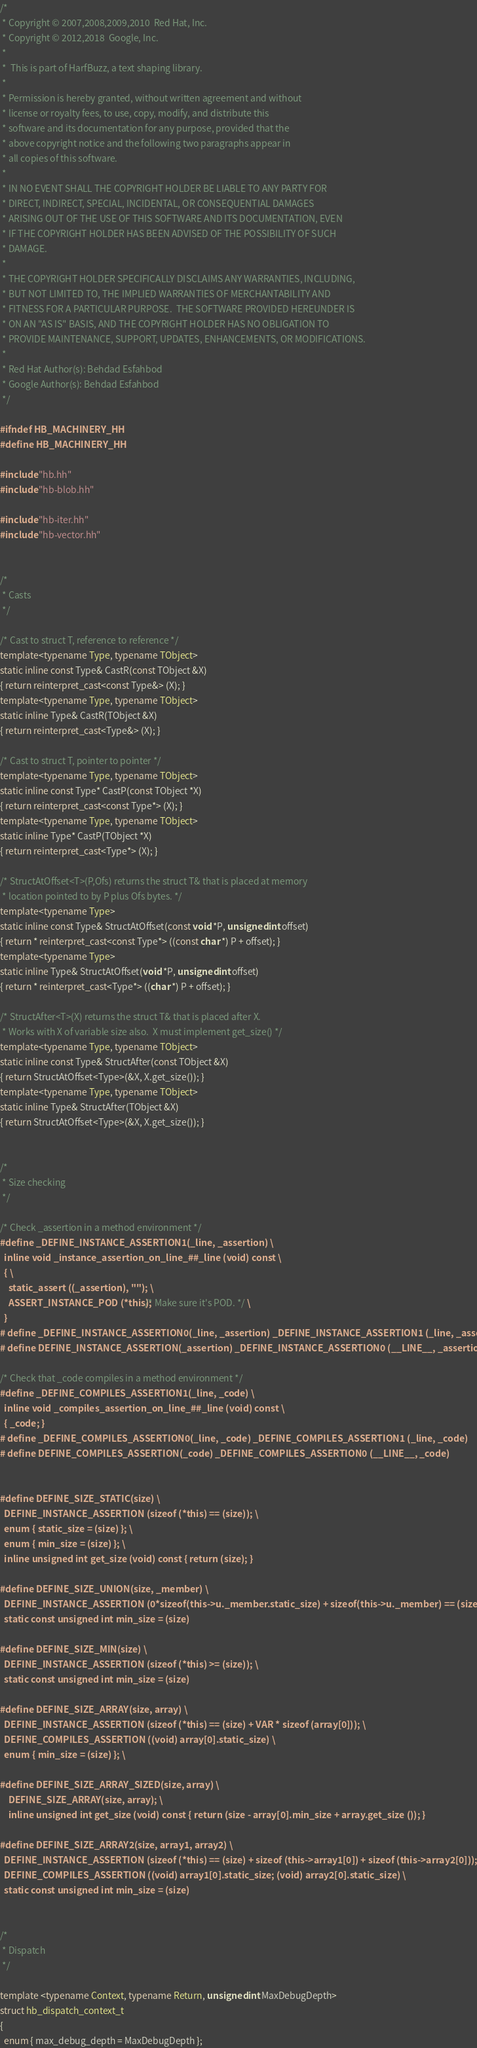Convert code to text. <code><loc_0><loc_0><loc_500><loc_500><_C++_>/*
 * Copyright © 2007,2008,2009,2010  Red Hat, Inc.
 * Copyright © 2012,2018  Google, Inc.
 *
 *  This is part of HarfBuzz, a text shaping library.
 *
 * Permission is hereby granted, without written agreement and without
 * license or royalty fees, to use, copy, modify, and distribute this
 * software and its documentation for any purpose, provided that the
 * above copyright notice and the following two paragraphs appear in
 * all copies of this software.
 *
 * IN NO EVENT SHALL THE COPYRIGHT HOLDER BE LIABLE TO ANY PARTY FOR
 * DIRECT, INDIRECT, SPECIAL, INCIDENTAL, OR CONSEQUENTIAL DAMAGES
 * ARISING OUT OF THE USE OF THIS SOFTWARE AND ITS DOCUMENTATION, EVEN
 * IF THE COPYRIGHT HOLDER HAS BEEN ADVISED OF THE POSSIBILITY OF SUCH
 * DAMAGE.
 *
 * THE COPYRIGHT HOLDER SPECIFICALLY DISCLAIMS ANY WARRANTIES, INCLUDING,
 * BUT NOT LIMITED TO, THE IMPLIED WARRANTIES OF MERCHANTABILITY AND
 * FITNESS FOR A PARTICULAR PURPOSE.  THE SOFTWARE PROVIDED HEREUNDER IS
 * ON AN "AS IS" BASIS, AND THE COPYRIGHT HOLDER HAS NO OBLIGATION TO
 * PROVIDE MAINTENANCE, SUPPORT, UPDATES, ENHANCEMENTS, OR MODIFICATIONS.
 *
 * Red Hat Author(s): Behdad Esfahbod
 * Google Author(s): Behdad Esfahbod
 */

#ifndef HB_MACHINERY_HH
#define HB_MACHINERY_HH

#include "hb.hh"
#include "hb-blob.hh"

#include "hb-iter.hh"
#include "hb-vector.hh"


/*
 * Casts
 */

/* Cast to struct T, reference to reference */
template<typename Type, typename TObject>
static inline const Type& CastR(const TObject &X)
{ return reinterpret_cast<const Type&> (X); }
template<typename Type, typename TObject>
static inline Type& CastR(TObject &X)
{ return reinterpret_cast<Type&> (X); }

/* Cast to struct T, pointer to pointer */
template<typename Type, typename TObject>
static inline const Type* CastP(const TObject *X)
{ return reinterpret_cast<const Type*> (X); }
template<typename Type, typename TObject>
static inline Type* CastP(TObject *X)
{ return reinterpret_cast<Type*> (X); }

/* StructAtOffset<T>(P,Ofs) returns the struct T& that is placed at memory
 * location pointed to by P plus Ofs bytes. */
template<typename Type>
static inline const Type& StructAtOffset(const void *P, unsigned int offset)
{ return * reinterpret_cast<const Type*> ((const char *) P + offset); }
template<typename Type>
static inline Type& StructAtOffset(void *P, unsigned int offset)
{ return * reinterpret_cast<Type*> ((char *) P + offset); }

/* StructAfter<T>(X) returns the struct T& that is placed after X.
 * Works with X of variable size also.  X must implement get_size() */
template<typename Type, typename TObject>
static inline const Type& StructAfter(const TObject &X)
{ return StructAtOffset<Type>(&X, X.get_size()); }
template<typename Type, typename TObject>
static inline Type& StructAfter(TObject &X)
{ return StructAtOffset<Type>(&X, X.get_size()); }


/*
 * Size checking
 */

/* Check _assertion in a method environment */
#define _DEFINE_INSTANCE_ASSERTION1(_line, _assertion) \
  inline void _instance_assertion_on_line_##_line (void) const \
  { \
    static_assert ((_assertion), ""); \
    ASSERT_INSTANCE_POD (*this); /* Make sure it's POD. */ \
  }
# define _DEFINE_INSTANCE_ASSERTION0(_line, _assertion) _DEFINE_INSTANCE_ASSERTION1 (_line, _assertion)
# define DEFINE_INSTANCE_ASSERTION(_assertion) _DEFINE_INSTANCE_ASSERTION0 (__LINE__, _assertion)

/* Check that _code compiles in a method environment */
#define _DEFINE_COMPILES_ASSERTION1(_line, _code) \
  inline void _compiles_assertion_on_line_##_line (void) const \
  { _code; }
# define _DEFINE_COMPILES_ASSERTION0(_line, _code) _DEFINE_COMPILES_ASSERTION1 (_line, _code)
# define DEFINE_COMPILES_ASSERTION(_code) _DEFINE_COMPILES_ASSERTION0 (__LINE__, _code)


#define DEFINE_SIZE_STATIC(size) \
  DEFINE_INSTANCE_ASSERTION (sizeof (*this) == (size)); \
  enum { static_size = (size) }; \
  enum { min_size = (size) }; \
  inline unsigned int get_size (void) const { return (size); }

#define DEFINE_SIZE_UNION(size, _member) \
  DEFINE_INSTANCE_ASSERTION (0*sizeof(this->u._member.static_size) + sizeof(this->u._member) == (size)); \
  static const unsigned int min_size = (size)

#define DEFINE_SIZE_MIN(size) \
  DEFINE_INSTANCE_ASSERTION (sizeof (*this) >= (size)); \
  static const unsigned int min_size = (size)

#define DEFINE_SIZE_ARRAY(size, array) \
  DEFINE_INSTANCE_ASSERTION (sizeof (*this) == (size) + VAR * sizeof (array[0])); \
  DEFINE_COMPILES_ASSERTION ((void) array[0].static_size) \
  enum { min_size = (size) }; \

#define DEFINE_SIZE_ARRAY_SIZED(size, array) \
	DEFINE_SIZE_ARRAY(size, array); \
	inline unsigned int get_size (void) const { return (size - array[0].min_size + array.get_size ()); }

#define DEFINE_SIZE_ARRAY2(size, array1, array2) \
  DEFINE_INSTANCE_ASSERTION (sizeof (*this) == (size) + sizeof (this->array1[0]) + sizeof (this->array2[0])); \
  DEFINE_COMPILES_ASSERTION ((void) array1[0].static_size; (void) array2[0].static_size) \
  static const unsigned int min_size = (size)


/*
 * Dispatch
 */

template <typename Context, typename Return, unsigned int MaxDebugDepth>
struct hb_dispatch_context_t
{
  enum { max_debug_depth = MaxDebugDepth };</code> 